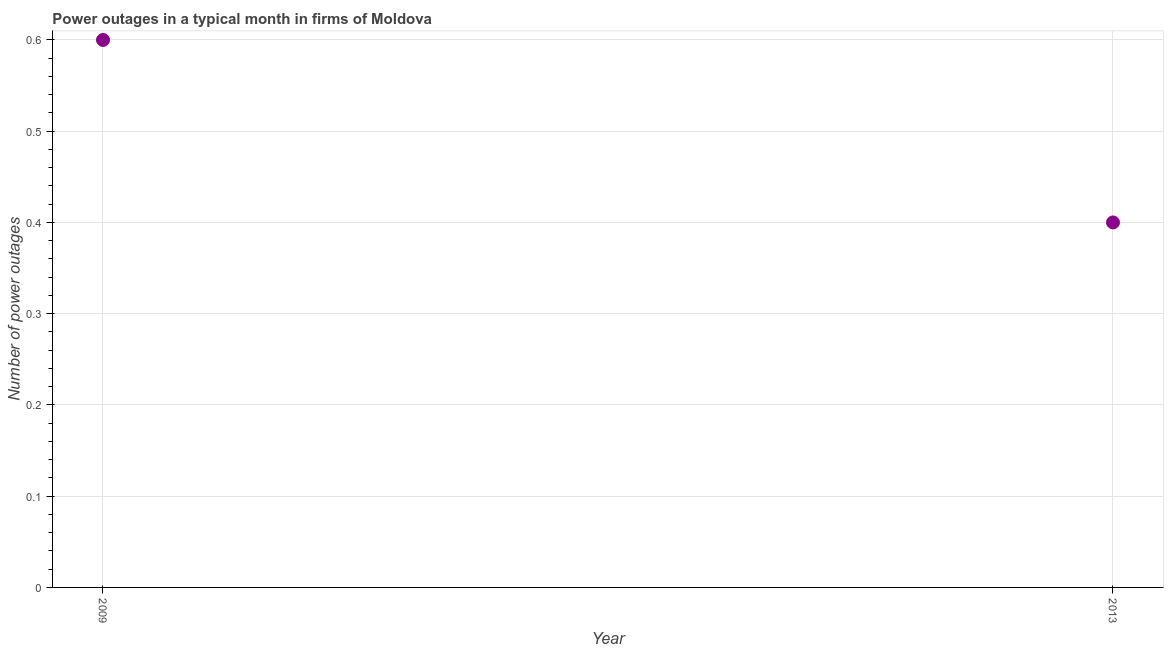Across all years, what is the maximum number of power outages?
Provide a short and direct response. 0.6. Across all years, what is the minimum number of power outages?
Give a very brief answer. 0.4. What is the difference between the number of power outages in 2009 and 2013?
Ensure brevity in your answer.  0.2. What is the average number of power outages per year?
Provide a succinct answer. 0.5. What is the median number of power outages?
Your response must be concise. 0.5. What is the ratio of the number of power outages in 2009 to that in 2013?
Your answer should be compact. 1.5. Does the number of power outages monotonically increase over the years?
Provide a succinct answer. No. Does the graph contain any zero values?
Your answer should be very brief. No. What is the title of the graph?
Provide a short and direct response. Power outages in a typical month in firms of Moldova. What is the label or title of the Y-axis?
Your answer should be compact. Number of power outages. What is the Number of power outages in 2013?
Provide a succinct answer. 0.4. 